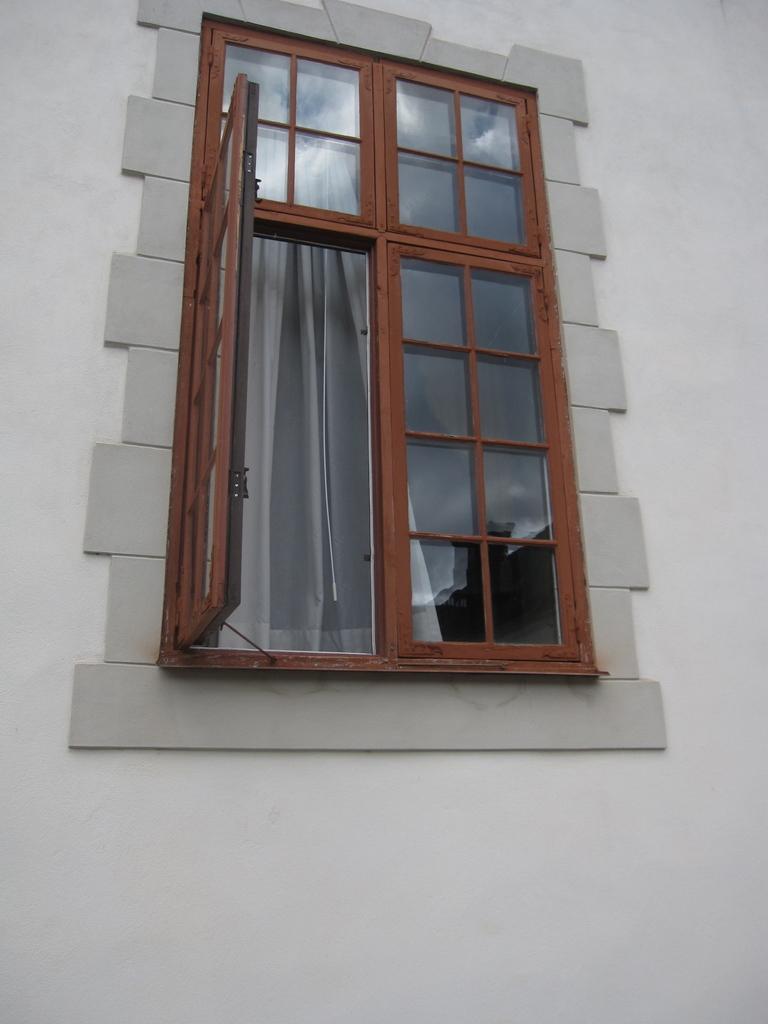Could you give a brief overview of what you see in this image? This picture might be taken outside of the building. In this image, in the middle, we can see a glass window, inside the glass window, we can see a curtain. In the background, we can see a wall which is in white color. 